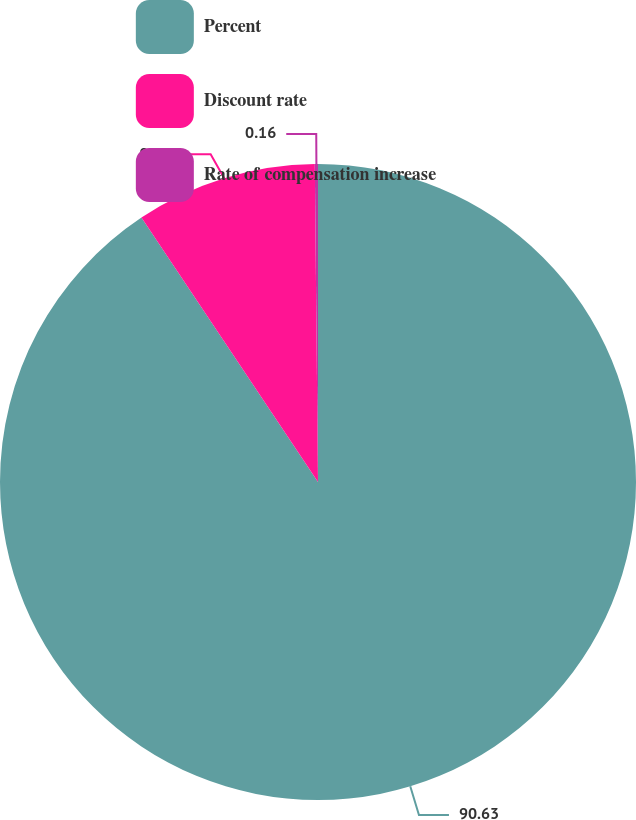Convert chart. <chart><loc_0><loc_0><loc_500><loc_500><pie_chart><fcel>Percent<fcel>Discount rate<fcel>Rate of compensation increase<nl><fcel>90.64%<fcel>9.21%<fcel>0.16%<nl></chart> 